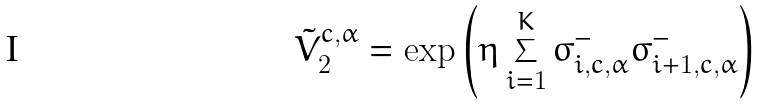<formula> <loc_0><loc_0><loc_500><loc_500>\tilde { V } ^ { c , \alpha } _ { 2 } = \exp { \left ( \eta \sum _ { i = 1 } ^ { K } \sigma ^ { - } _ { i , c , \alpha } \sigma ^ { - } _ { i + 1 , c , \alpha } \right ) }</formula> 